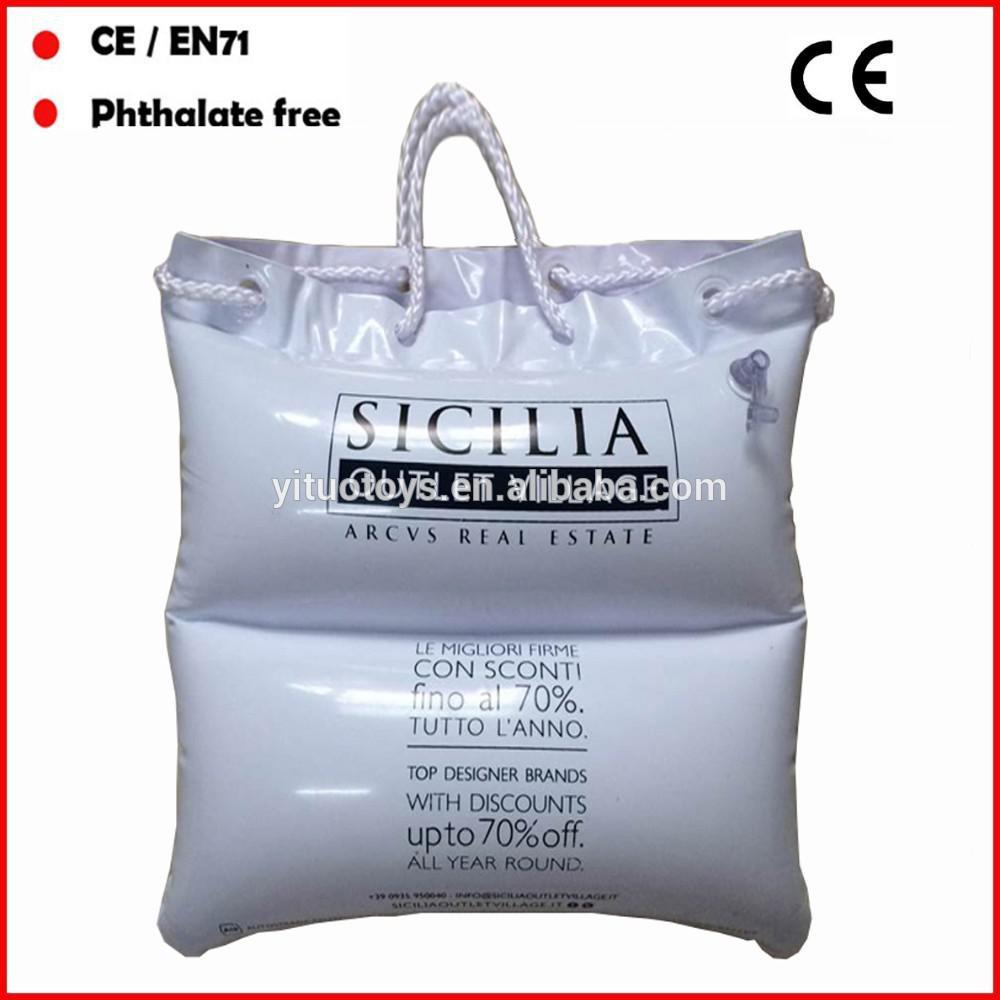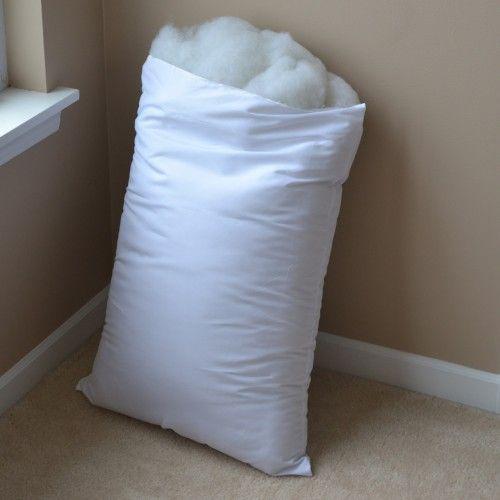The first image is the image on the left, the second image is the image on the right. Assess this claim about the two images: "The left and right image contains the same number of pillows in pillow bags.". Correct or not? Answer yes or no. No. 